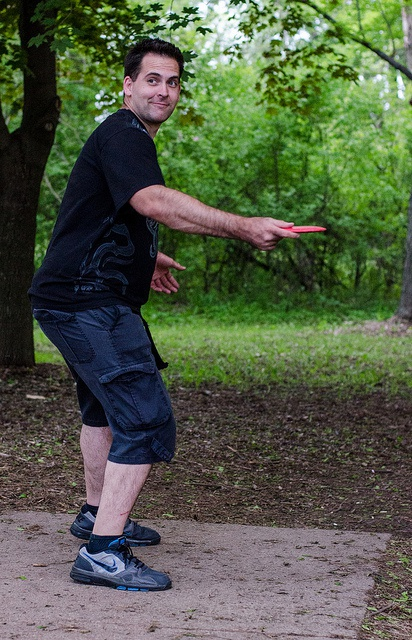Describe the objects in this image and their specific colors. I can see people in darkgreen, black, navy, darkgray, and gray tones and frisbee in darkgreen, salmon, lightpink, and black tones in this image. 